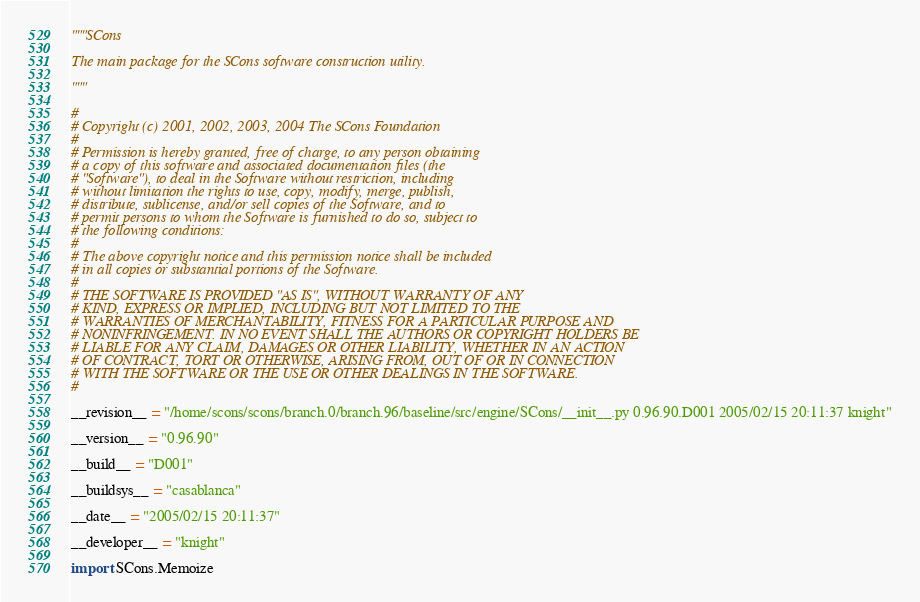Convert code to text. <code><loc_0><loc_0><loc_500><loc_500><_Python_>"""SCons

The main package for the SCons software construction utility.

"""

#
# Copyright (c) 2001, 2002, 2003, 2004 The SCons Foundation
#
# Permission is hereby granted, free of charge, to any person obtaining
# a copy of this software and associated documentation files (the
# "Software"), to deal in the Software without restriction, including
# without limitation the rights to use, copy, modify, merge, publish,
# distribute, sublicense, and/or sell copies of the Software, and to
# permit persons to whom the Software is furnished to do so, subject to
# the following conditions:
#
# The above copyright notice and this permission notice shall be included
# in all copies or substantial portions of the Software.
#
# THE SOFTWARE IS PROVIDED "AS IS", WITHOUT WARRANTY OF ANY
# KIND, EXPRESS OR IMPLIED, INCLUDING BUT NOT LIMITED TO THE
# WARRANTIES OF MERCHANTABILITY, FITNESS FOR A PARTICULAR PURPOSE AND
# NONINFRINGEMENT. IN NO EVENT SHALL THE AUTHORS OR COPYRIGHT HOLDERS BE
# LIABLE FOR ANY CLAIM, DAMAGES OR OTHER LIABILITY, WHETHER IN AN ACTION
# OF CONTRACT, TORT OR OTHERWISE, ARISING FROM, OUT OF OR IN CONNECTION
# WITH THE SOFTWARE OR THE USE OR OTHER DEALINGS IN THE SOFTWARE.
#

__revision__ = "/home/scons/scons/branch.0/branch.96/baseline/src/engine/SCons/__init__.py 0.96.90.D001 2005/02/15 20:11:37 knight"

__version__ = "0.96.90"

__build__ = "D001"

__buildsys__ = "casablanca"

__date__ = "2005/02/15 20:11:37"

__developer__ = "knight"

import SCons.Memoize
</code> 